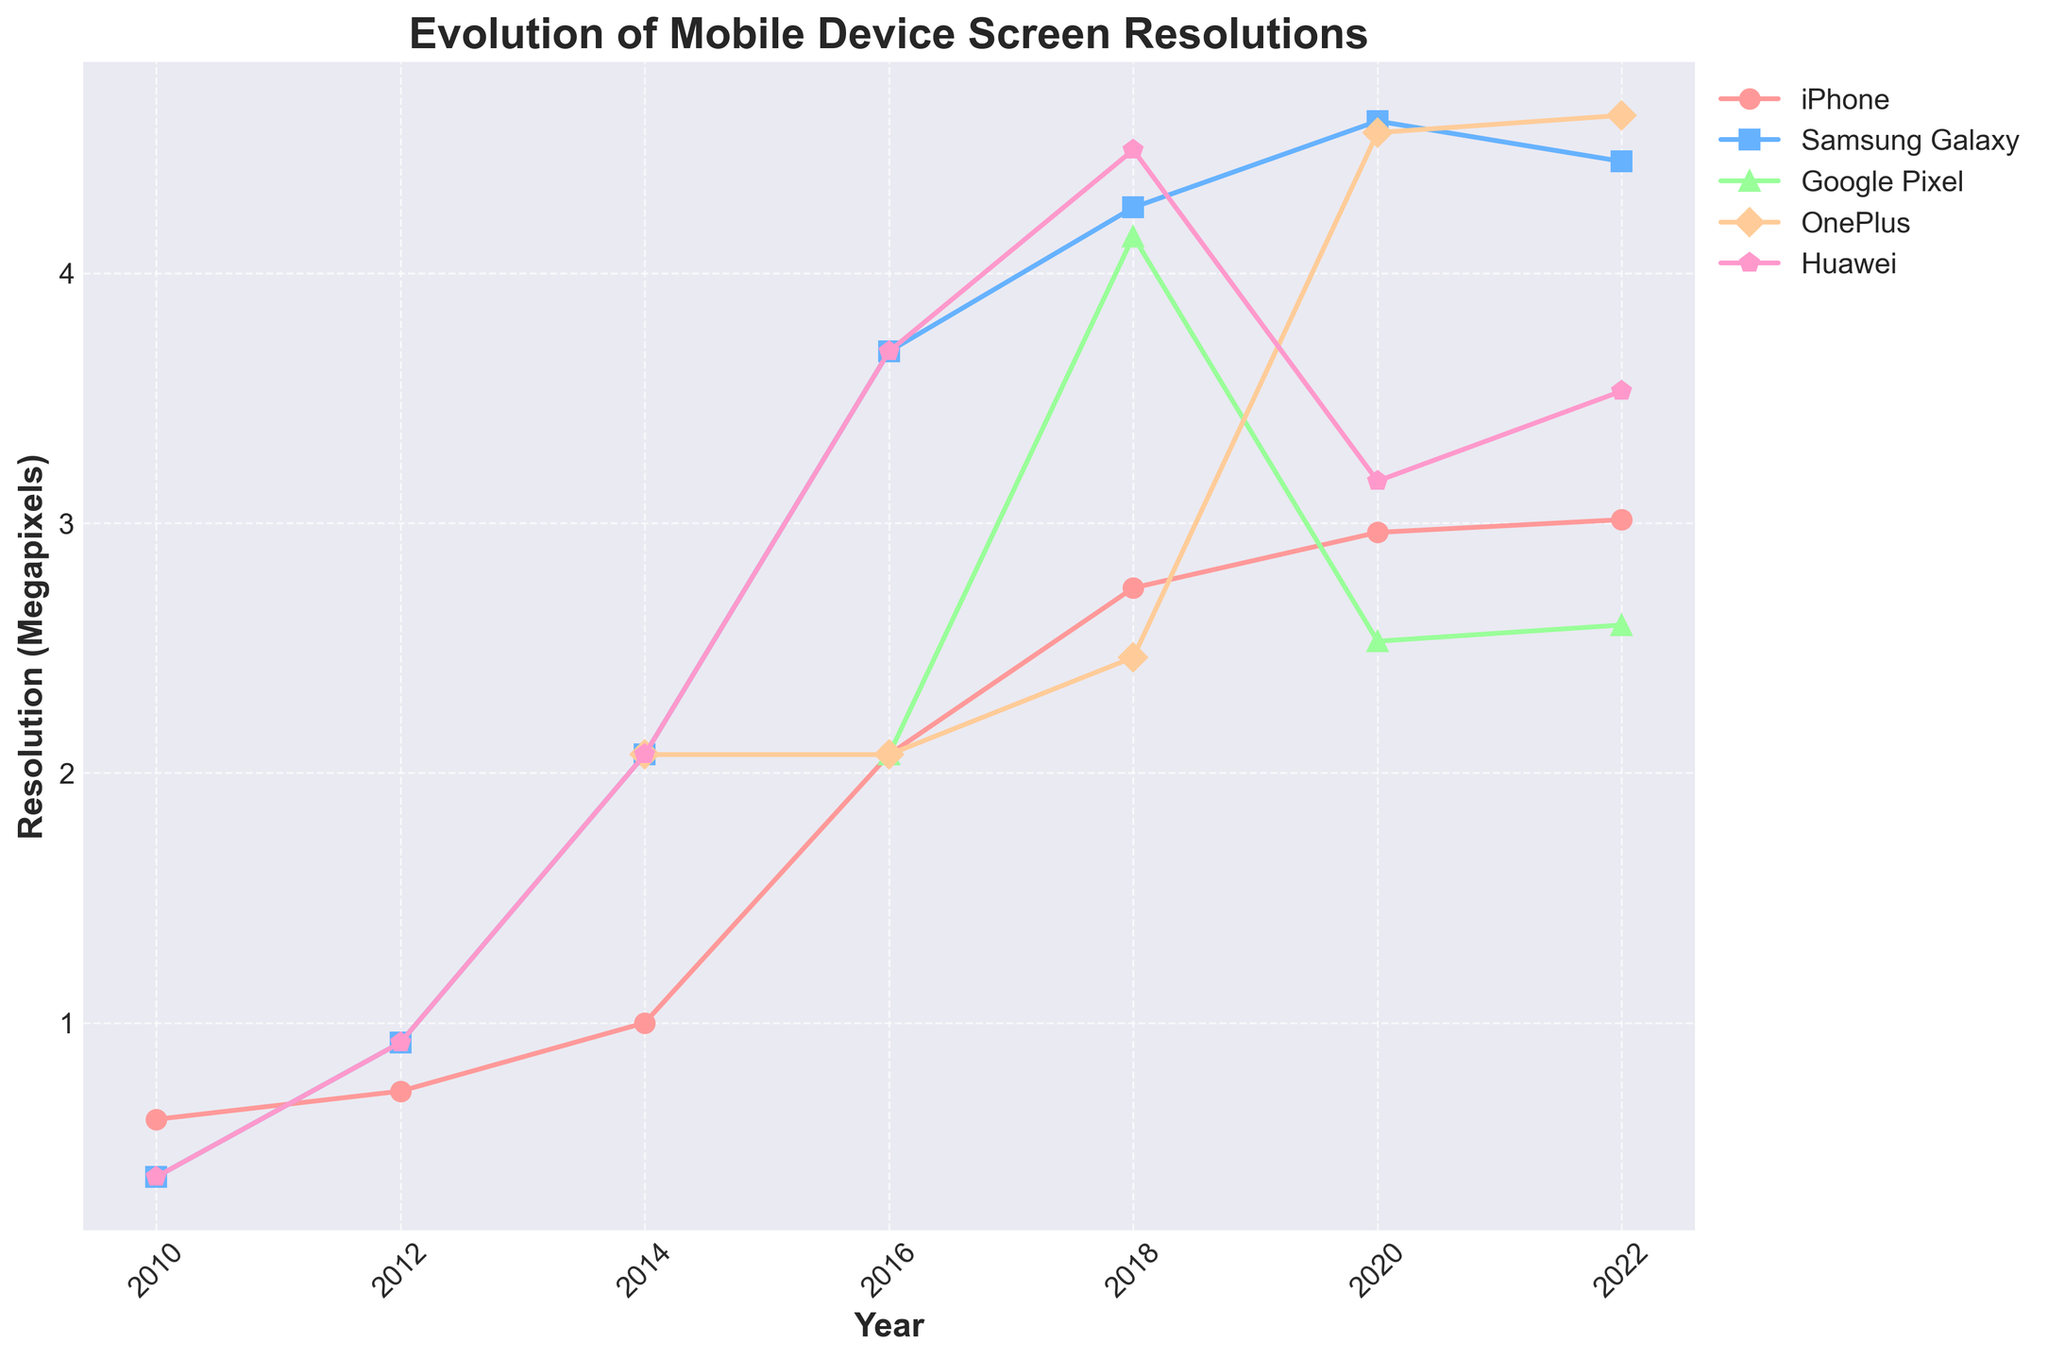What trend can be observed in the resolution of Samsung Galaxy from 2010 to 2022? To interpret this, observe the line representing Samsung Galaxy, noting its increase: from 800x480 in 2010, to 3200x1440 in 2020, and slightly decreasing to 3088x1440 in 2022. This shows a significant overall increase with a slight decline at the end.
Answer: Significant overall increase with slight decline at the end Which device had the highest screen resolution in 2018, and what was the resolution? By examining the highest points on the chart for 2018 and identifying the corresponding color and marker, Huawei had the highest screen resolution at 3120x1440.
Answer: Huawei, 3120x1440 Between 2014 and 2020, which device showed the largest increase in screen resolution in megapixels? Calculate the difference in resolution across devices: 
- iPhone: (2532*1170 / 1e6) - (1334*750 / 1e6),
- Samsung Galaxy: (3200*1440 / 1e6) - (1920*1080 / 1e6), 
- etc. Samsung Galaxy shows the largest increase in this timeframe.
Answer: Samsung Galaxy Which device consistently showed a resolution greater than 2 million pixels from 2016 onwards? Check devices’ resolution (in megapixels) from 2016 onwards; Google Pixel consistently has resolutions exceeding 2 million pixels across these years (from 1920x1080 in 2016).
Answer: Google Pixel How did the resolution of the OnePlus change from 2018 to 2022? Look at OnePlus's resolutions: 2280x1080 in 2018 to 3216x1440 in 2022, calculate the increase: 
2018: 2280 x 1080 = 2.4624 Megapixels, 
2022: 3216 x 1440 = 4.633536 Megapixels. 
From 2.4624MP to 4.633536MP illustrates a substantial increase.
Answer: Significant increase In what year did the iPhone's screen resolution surpass 2 million pixels for the first time? Observe the iPhone line and look for the first year its resolution exceeds 2 million pixels. The resolution surpasses the threshold in 2016 (1920x1080).
Answer: 2016 In 2020, which device had a lower screen resolution, OnePlus or Huawei? Compare OnePlus's and Huawei's resolutions for 2020: OnePlus (3168x1440 megapixels) and Huawei (2640x1200 megapixels). Huawei’s is lesser.
Answer: Huawei Across all years, which two devices showed the most similar trend in screen resolution changes? By visually comparing the lines and their changes over the years, iPhone and Google Pixel appear to have the most similar trends over time.
Answer: iPhone and Google Pixel 